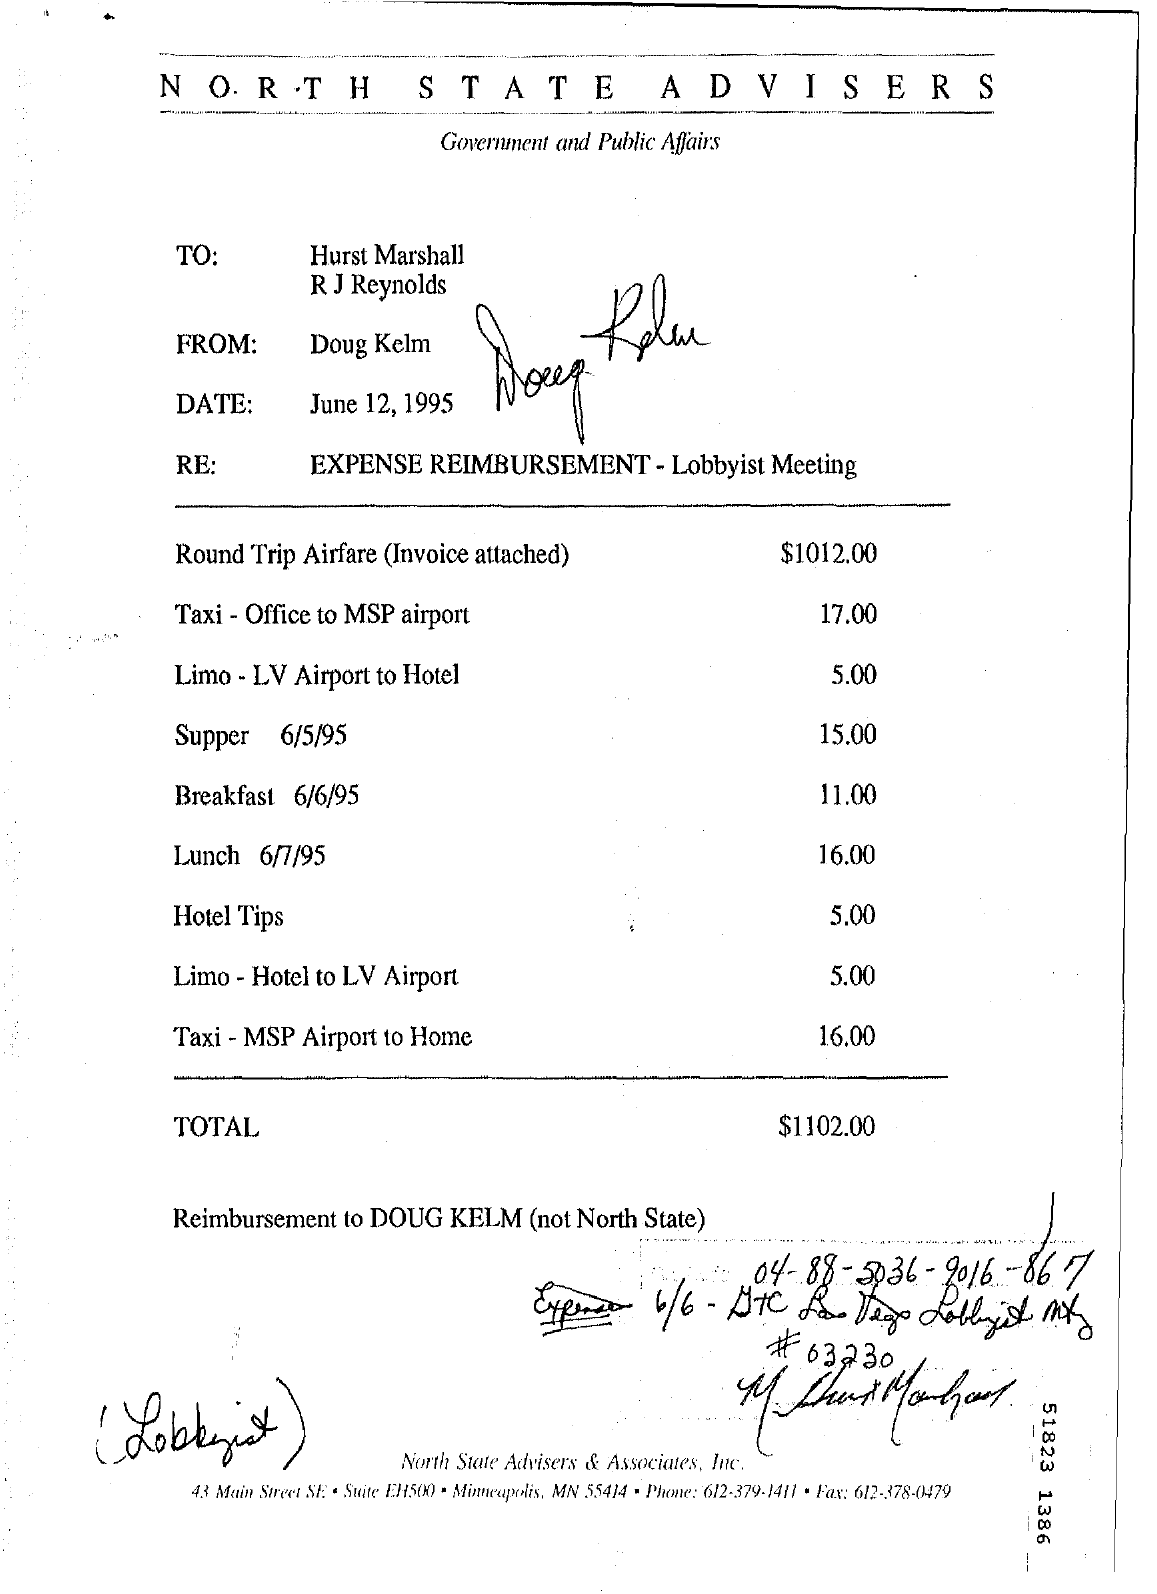Who is the Memorandum from ?
Make the answer very short. Doug kelm. When is the Memorandum dated on ?
Your answer should be very brief. June 12, 1995. What is the Lunch Date?
Provide a succinct answer. 6/7/95. What is the Breakfast Date ?
Provide a succinct answer. 6/6/95. 